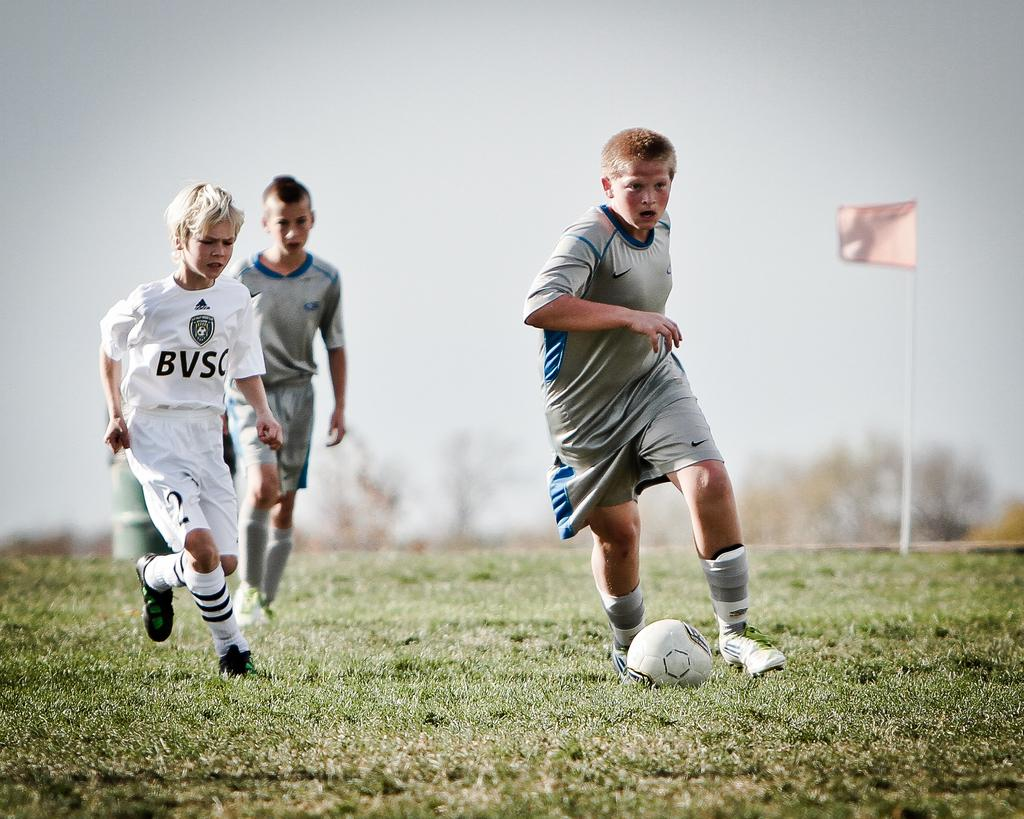How many sports persons are in the image? There are three sports persons in the image. Where are the sports persons located? The sports persons are on a field. What are the sports persons wearing that indicates their role? The sports persons are wearing jerseys. What type of footwear are the sports persons wearing? The sports persons are wearing shoes. What type of fish can be seen swimming in the veins of the sports persons in the image? There are no fish or veins visible in the image; the sports persons are wearing jerseys and shoes. 